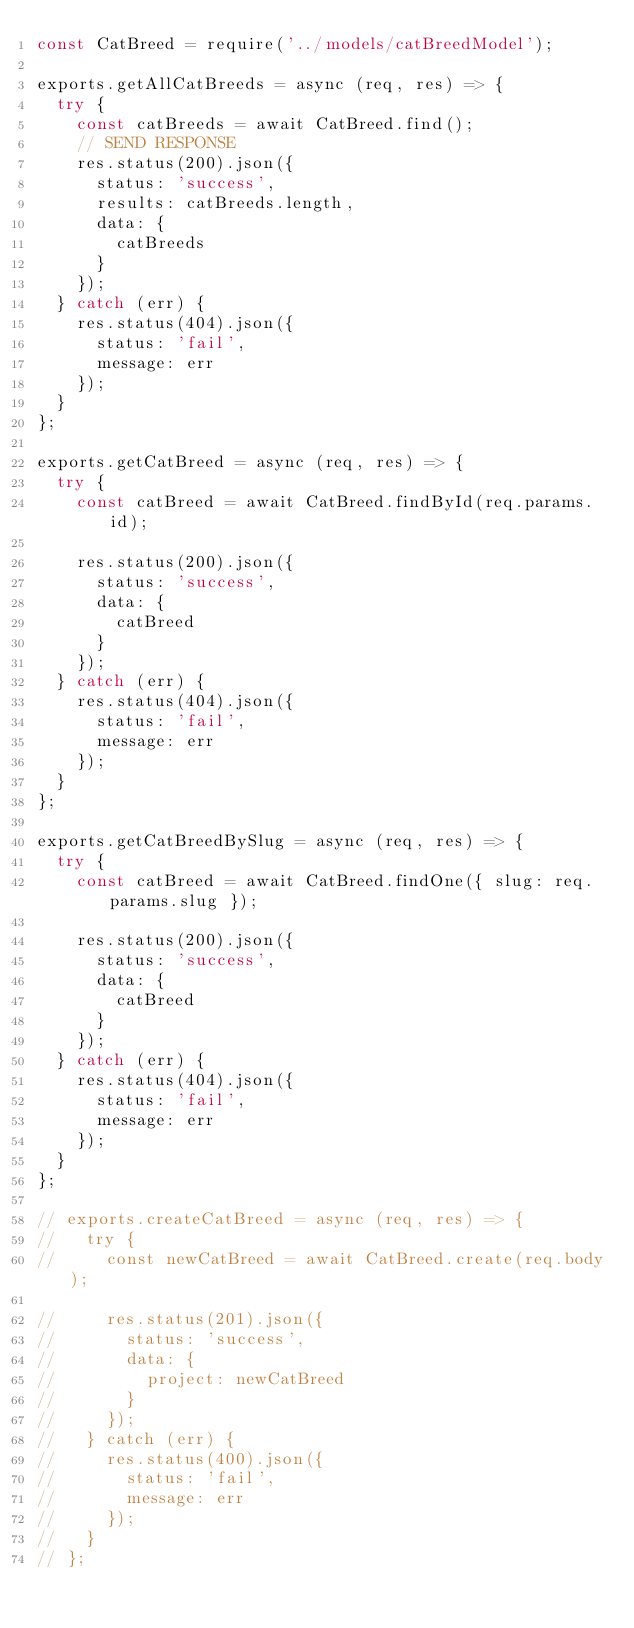Convert code to text. <code><loc_0><loc_0><loc_500><loc_500><_JavaScript_>const CatBreed = require('../models/catBreedModel');

exports.getAllCatBreeds = async (req, res) => {
  try {
    const catBreeds = await CatBreed.find();
    // SEND RESPONSE
    res.status(200).json({
      status: 'success',
      results: catBreeds.length,
      data: {
        catBreeds
      }
    });
  } catch (err) {
    res.status(404).json({
      status: 'fail',
      message: err
    });
  }
};

exports.getCatBreed = async (req, res) => {
  try {
    const catBreed = await CatBreed.findById(req.params.id);

    res.status(200).json({
      status: 'success',
      data: {
        catBreed
      }
    });
  } catch (err) {
    res.status(404).json({
      status: 'fail',
      message: err
    });
  }
};

exports.getCatBreedBySlug = async (req, res) => {
  try {
    const catBreed = await CatBreed.findOne({ slug: req.params.slug });

    res.status(200).json({
      status: 'success',
      data: {
        catBreed
      }
    });
  } catch (err) {
    res.status(404).json({
      status: 'fail',
      message: err
    });
  }
};

// exports.createCatBreed = async (req, res) => {
//   try {
//     const newCatBreed = await CatBreed.create(req.body);

//     res.status(201).json({
//       status: 'success',
//       data: {
//         project: newCatBreed
//       }
//     });
//   } catch (err) {
//     res.status(400).json({
//       status: 'fail',
//       message: err
//     });
//   }
// };
</code> 